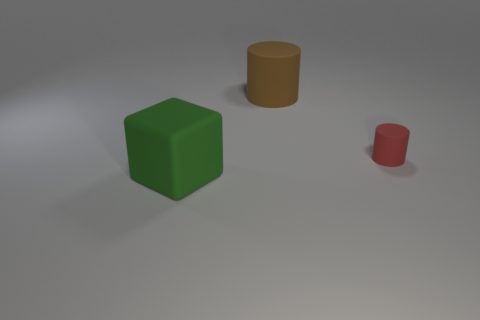What material is the large thing behind the matte thing that is left of the big cylinder? Based on the visual characteristics in the image, the large thing behind the matte object, which is a green cube on the left side of a big cylinder, appears to be made of a digital 3D model material with a plastic-like texture. However, without additional context or information, it is not possible to determine with certainty the exact type of material it intends to simulate. 